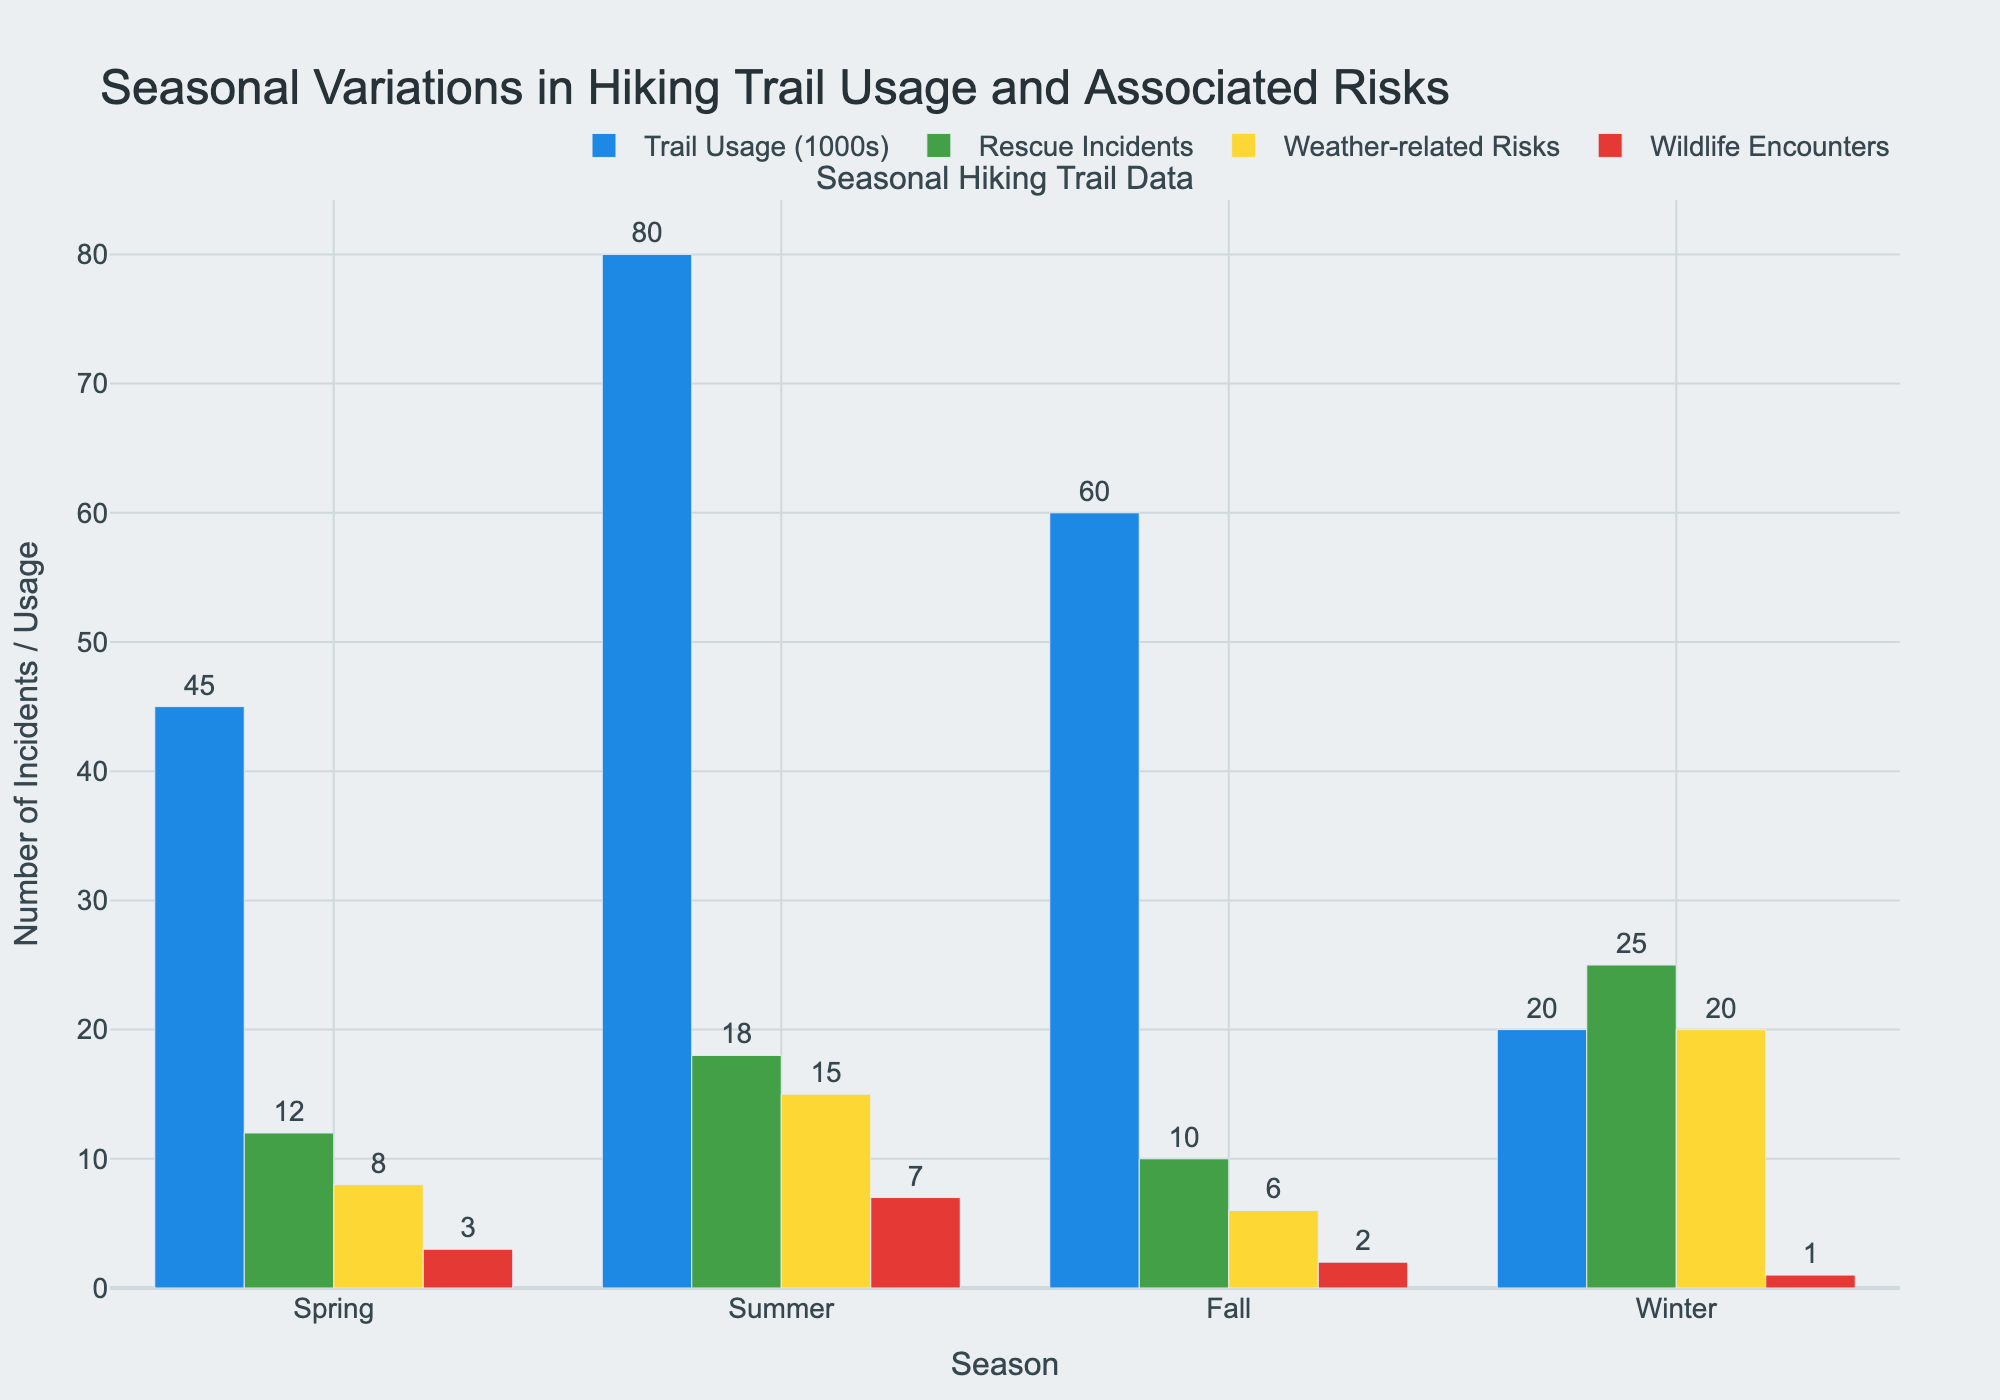How does the number of rescue incidents in winter compare to summer? Locate the bars that represent "Rescue Incidents" for Winter and Summer. The Winter bar is taller (25) compared to the Summer bar (18).
Answer: Winter has more rescue incidents than summer Considering weather-related risks, which season has the highest number and which has the lowest? Identify the bars representing "Weather-related Risks." The largest bar is in Winter (20) and the smallest in Fall (6).
Answer: Winter has the highest, and Fall has the lowest What’s the total number of trail usages across all seasons? Sum the values for "Trail Usage (1000s)" from each season: 45 (Spring) + 80 (Summer) + 60 (Fall) + 20 (Winter) = 205.
Answer: 205 Which season has the fewest wildlife encounters? Compare the heights of the bars representing "Wildlife Encounters." The Winter bar (1) is the shortest.
Answer: Winter Is there any season where trail usage exceeds 70,000 hikers? Identify the bars representing "Trail Usage (1000s)." Only the Summer bar is above 70 (80).
Answer: Yes, Summer In which season is the disparity between trail usage and rescue incidents the largest? Compare the differences between trail usage and rescue incidents for each season. Winter shows the largest gap with 20 (usage) and 25 (rescue), difference = 5.
Answer: Winter How many total rescue incidents occurred in Spring and Fall combined? Add the values for "Rescue Incidents" from Spring and Fall: 12 (Spring) + 10 (Fall) = 22.
Answer: 22 Which season has the most evenly distributed risks across different categories? Compare the height of the bars for each season. Spring has relatively balanced values for rescue incidents (12), weather-related risks (8), and wildlife encounters (3).
Answer: Spring 